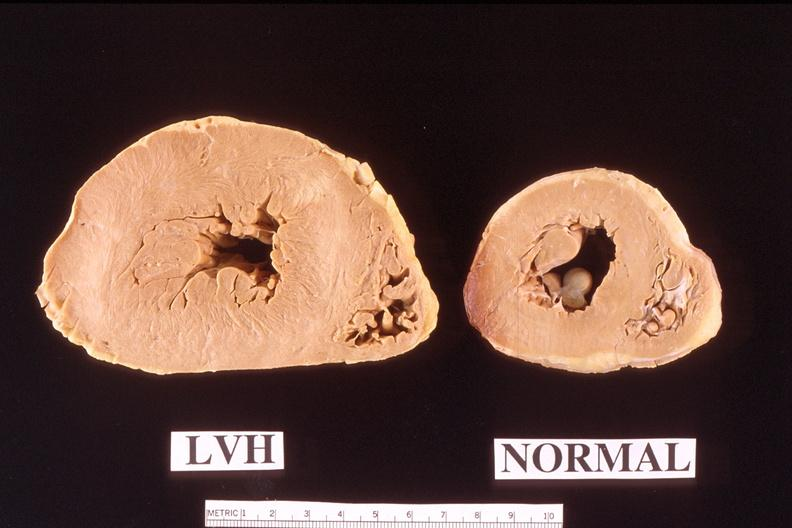s muscle atrophy present?
Answer the question using a single word or phrase. No 